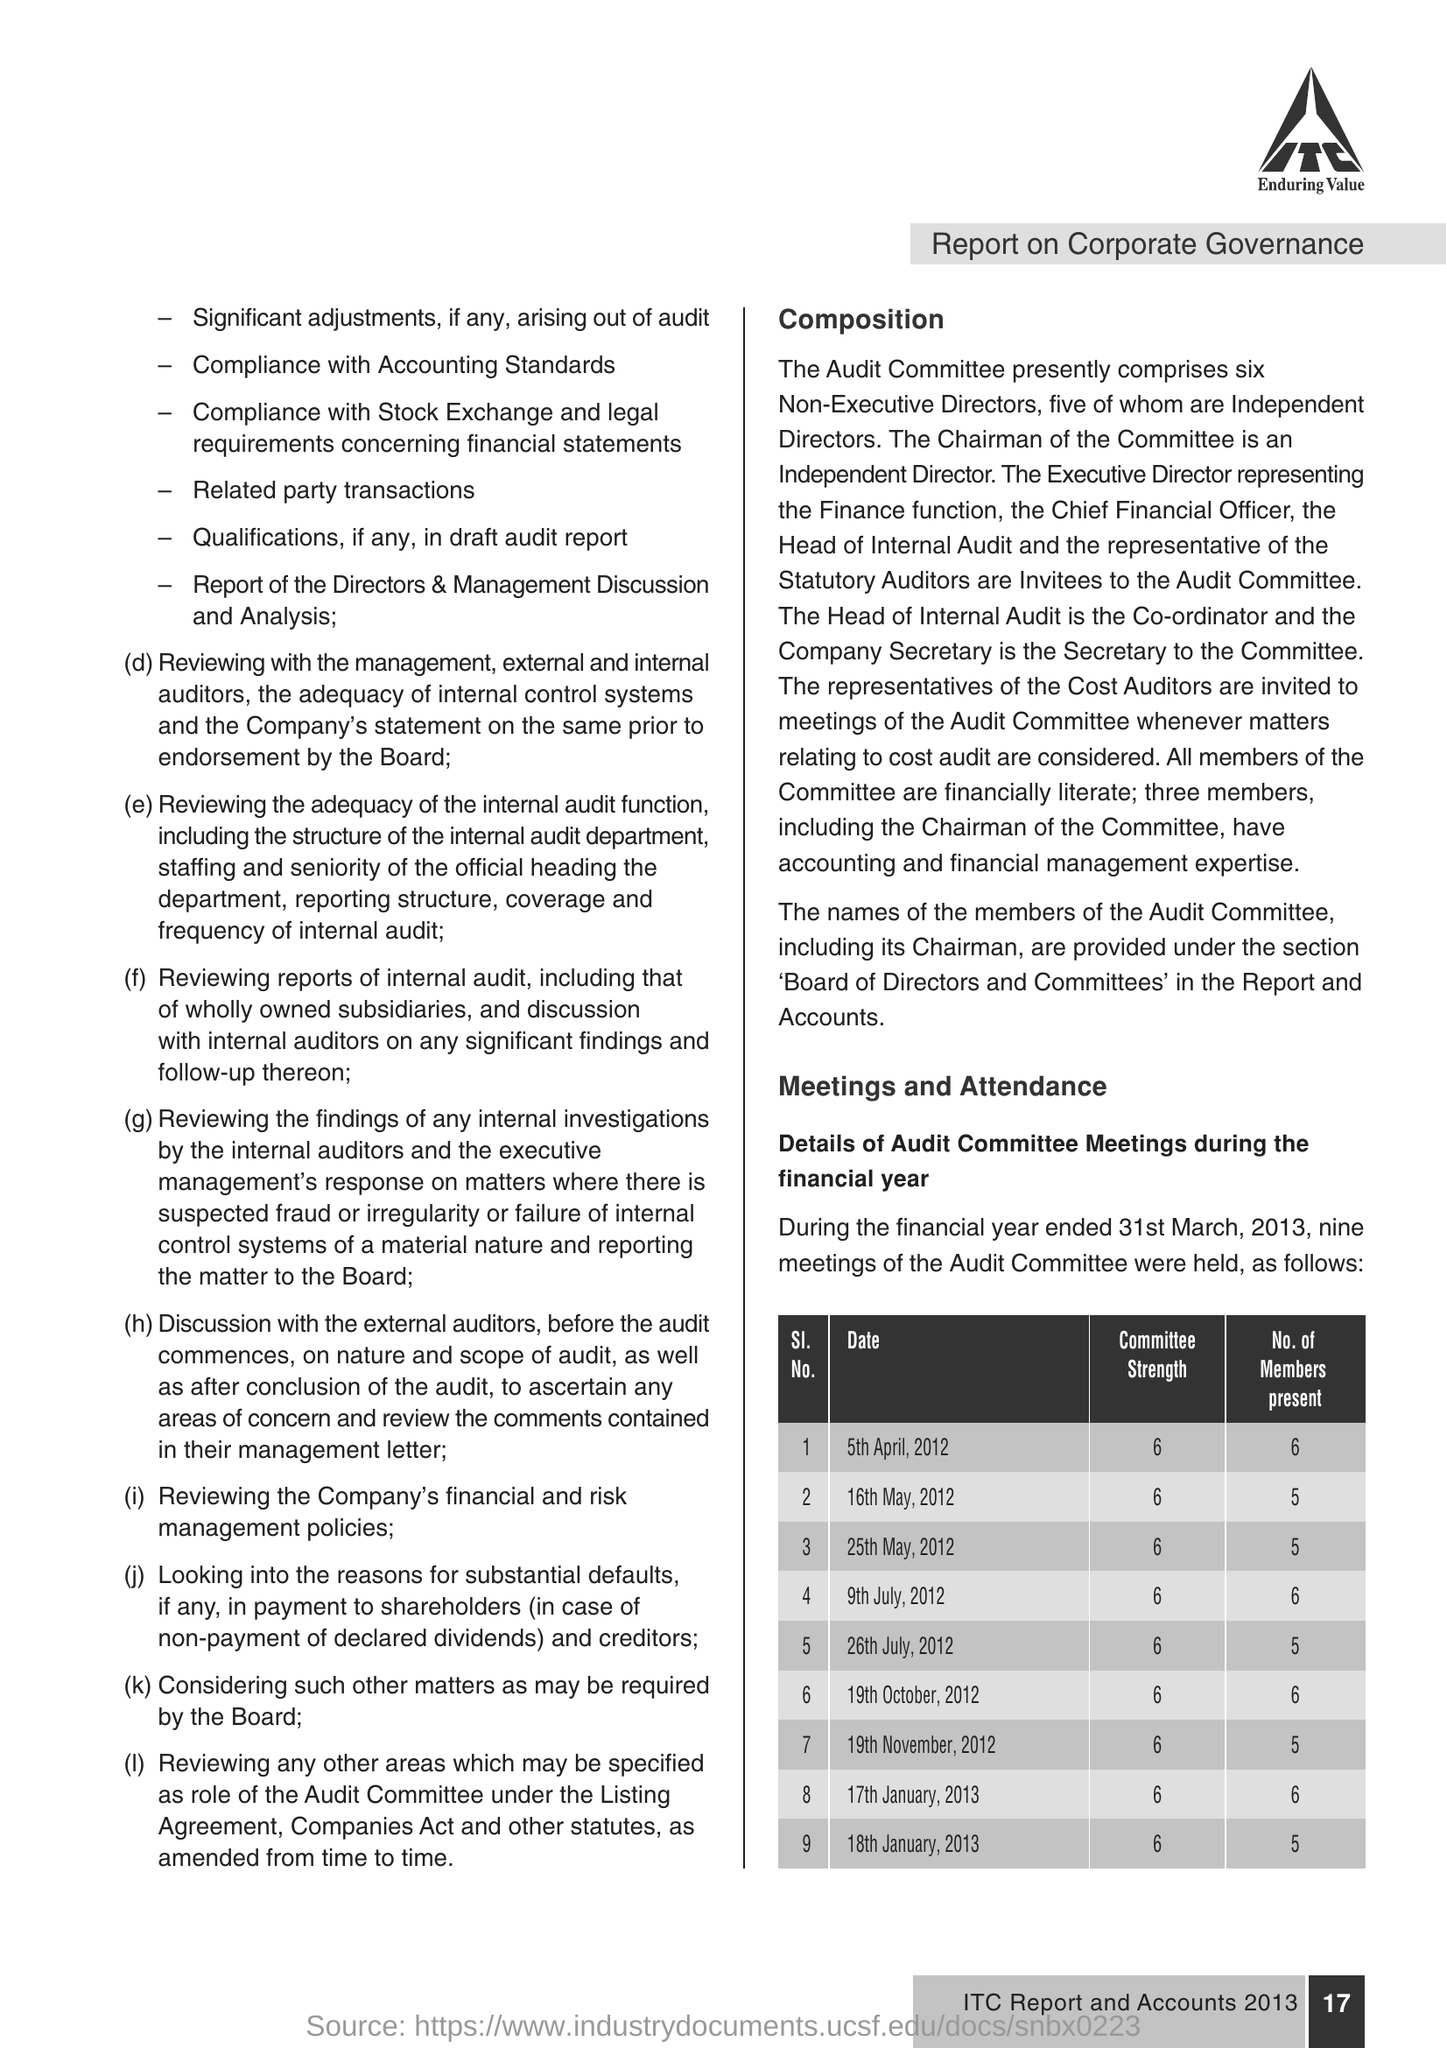How many Members present in 16th  May, 2012 ?
Your answer should be compact. 5. How much Committee strength in 9th July, 2012 ?
Offer a terse response. 6. 